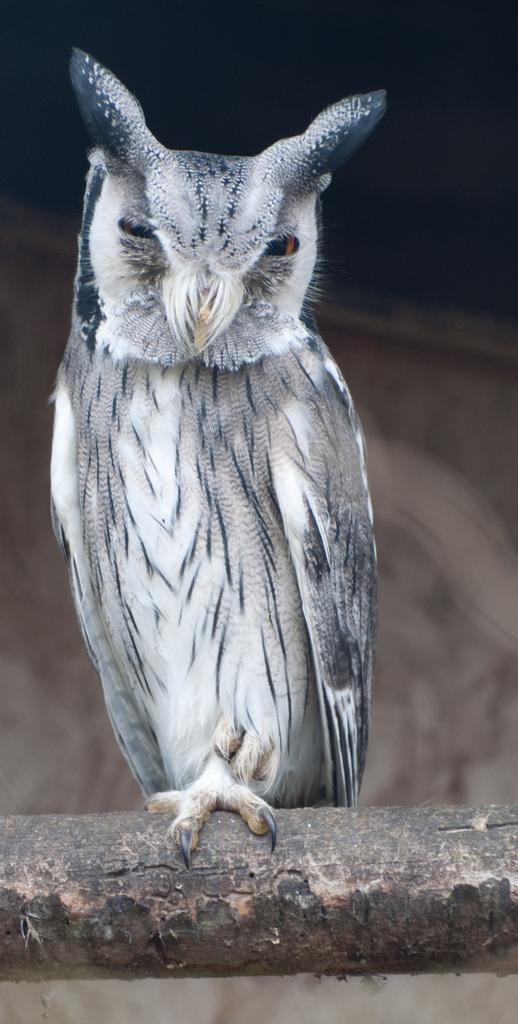Can you describe this image briefly? In the center of the image there is a bird. 